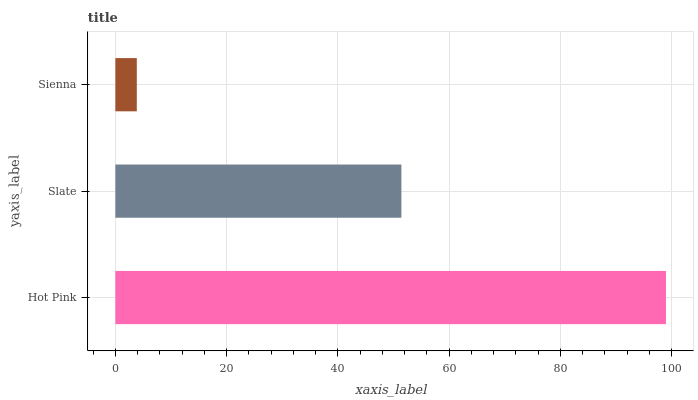Is Sienna the minimum?
Answer yes or no. Yes. Is Hot Pink the maximum?
Answer yes or no. Yes. Is Slate the minimum?
Answer yes or no. No. Is Slate the maximum?
Answer yes or no. No. Is Hot Pink greater than Slate?
Answer yes or no. Yes. Is Slate less than Hot Pink?
Answer yes or no. Yes. Is Slate greater than Hot Pink?
Answer yes or no. No. Is Hot Pink less than Slate?
Answer yes or no. No. Is Slate the high median?
Answer yes or no. Yes. Is Slate the low median?
Answer yes or no. Yes. Is Hot Pink the high median?
Answer yes or no. No. Is Sienna the low median?
Answer yes or no. No. 